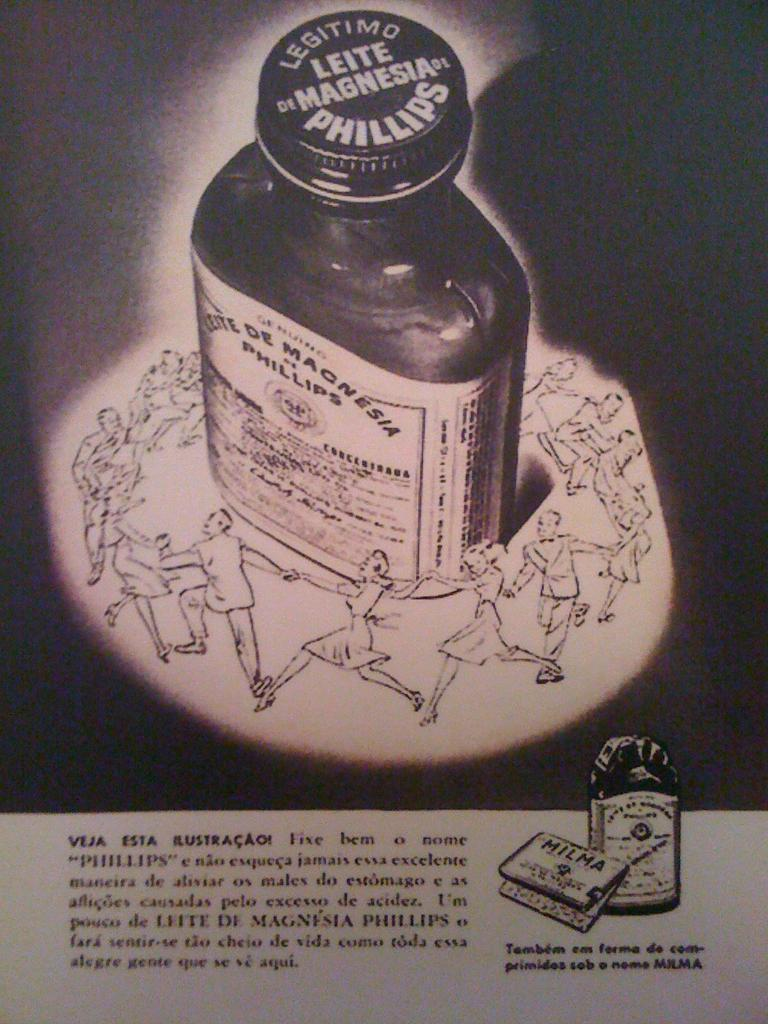<image>
Write a terse but informative summary of the picture. An advertisement for Legitimo Leite de Magnesia by Phillips. 